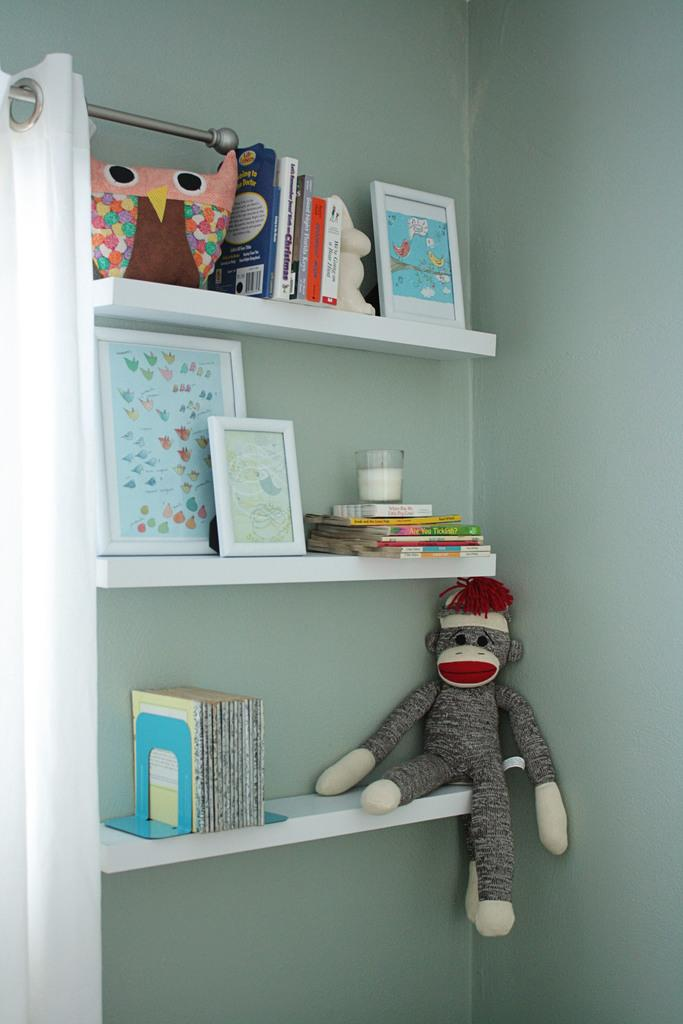What type of items can be seen in the image? There are books, picture frames, and a doll in the image. What is the arrangement of these items? The items are placed on shelves in the image. What is present on the left side of the image? There is a curtain on a rod on the left side of the image. What type of plastic is used to make the popcorn in the image? There is no popcorn present in the image, so it is not possible to determine the type of plastic used. How many children are visible in the image? There are no children visible in the image. 